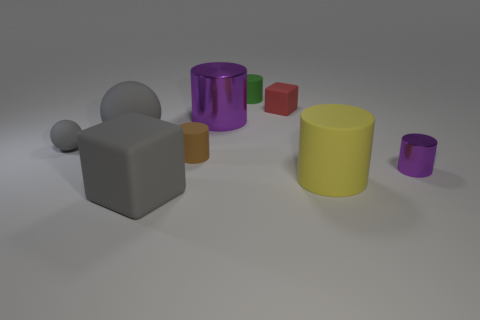There is a big sphere that is made of the same material as the small ball; what color is it?
Your response must be concise. Gray. Is there anything else that has the same size as the red block?
Make the answer very short. Yes. What number of things are either tiny rubber things that are on the left side of the green cylinder or rubber things behind the tiny purple metallic cylinder?
Provide a succinct answer. 5. There is a purple metallic cylinder in front of the tiny brown matte thing; does it have the same size as the purple metallic cylinder that is to the left of the red matte block?
Provide a short and direct response. No. There is another metal thing that is the same shape as the small purple metallic object; what is its color?
Make the answer very short. Purple. Are there any other things that are the same shape as the small metal thing?
Your answer should be very brief. Yes. Is the number of gray rubber things on the right side of the tiny gray ball greater than the number of small red matte things to the left of the small matte block?
Provide a succinct answer. Yes. There is a rubber block behind the metal cylinder that is behind the purple cylinder that is to the right of the big purple cylinder; what is its size?
Your answer should be very brief. Small. Does the yellow cylinder have the same material as the small sphere left of the tiny cube?
Give a very brief answer. Yes. Is the small green object the same shape as the tiny purple thing?
Your answer should be very brief. Yes. 